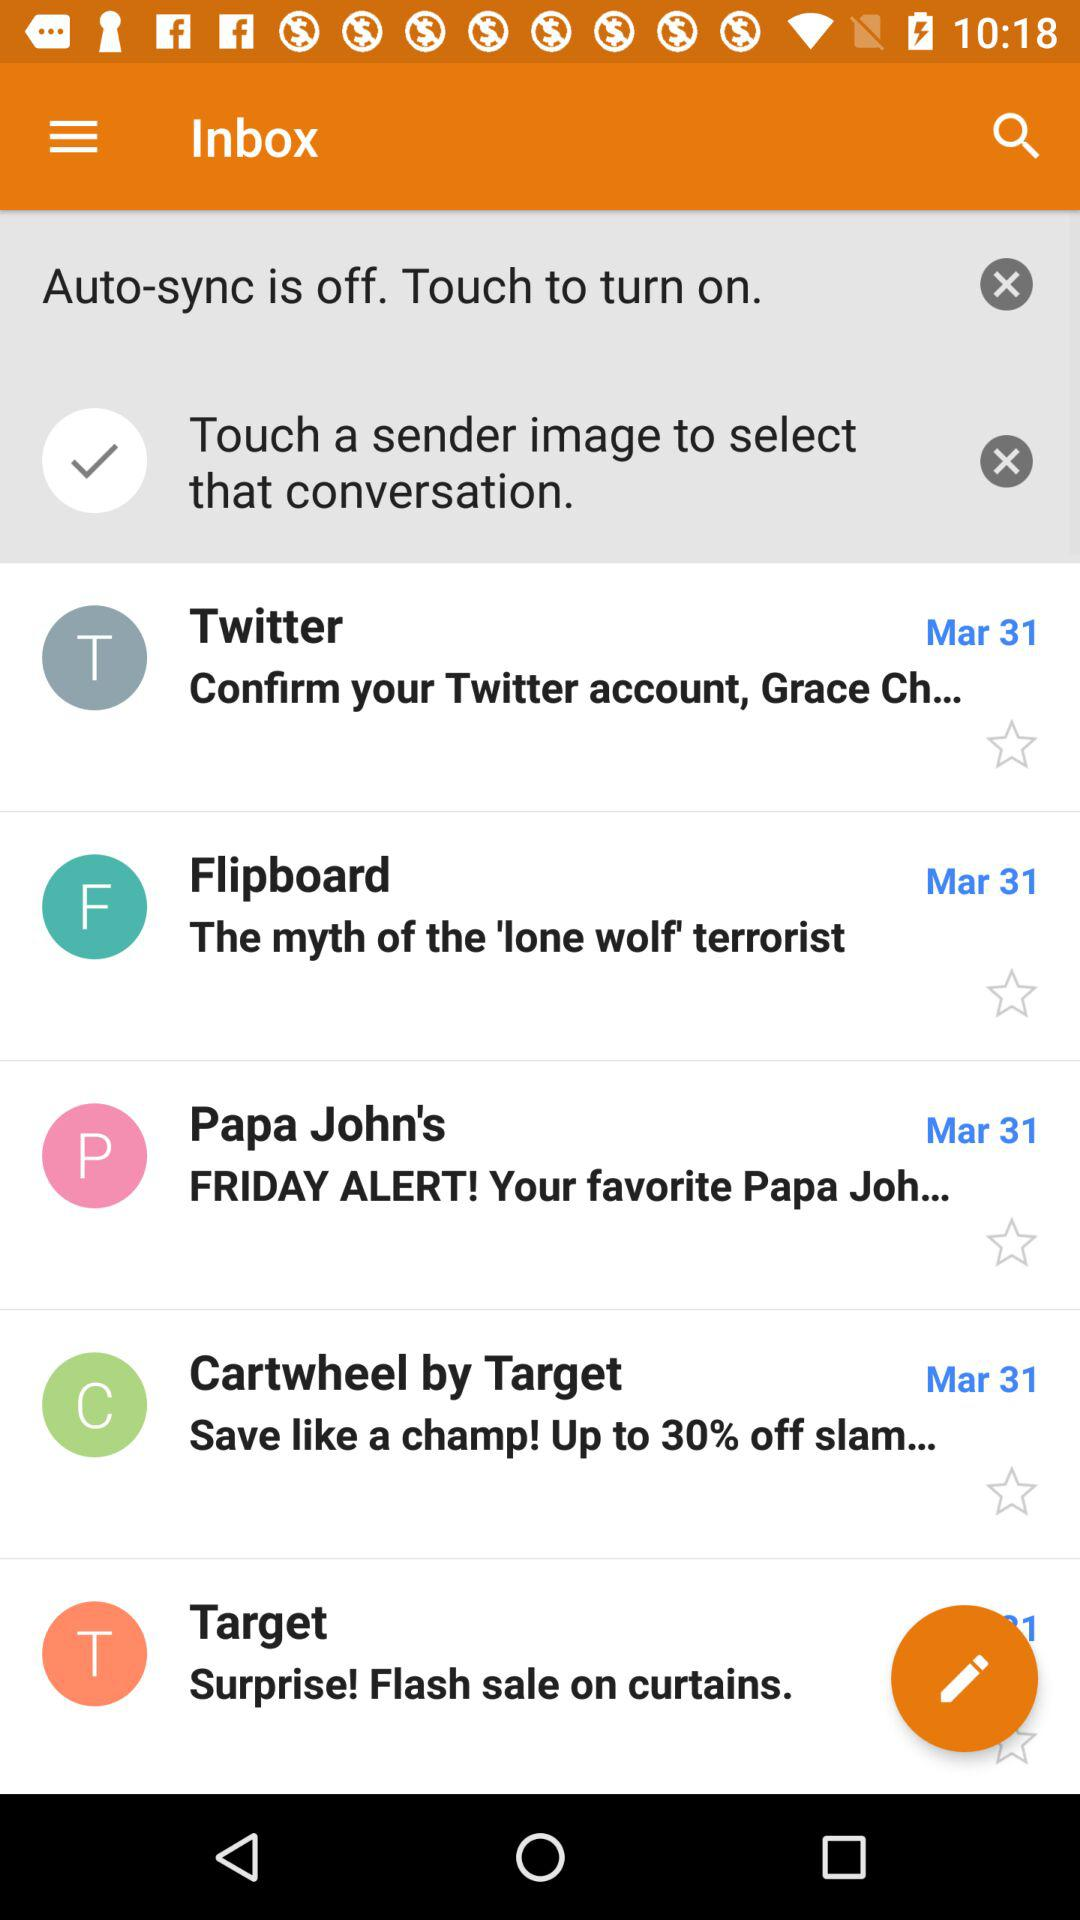How many items have a date next to them?
Answer the question using a single word or phrase. 5 